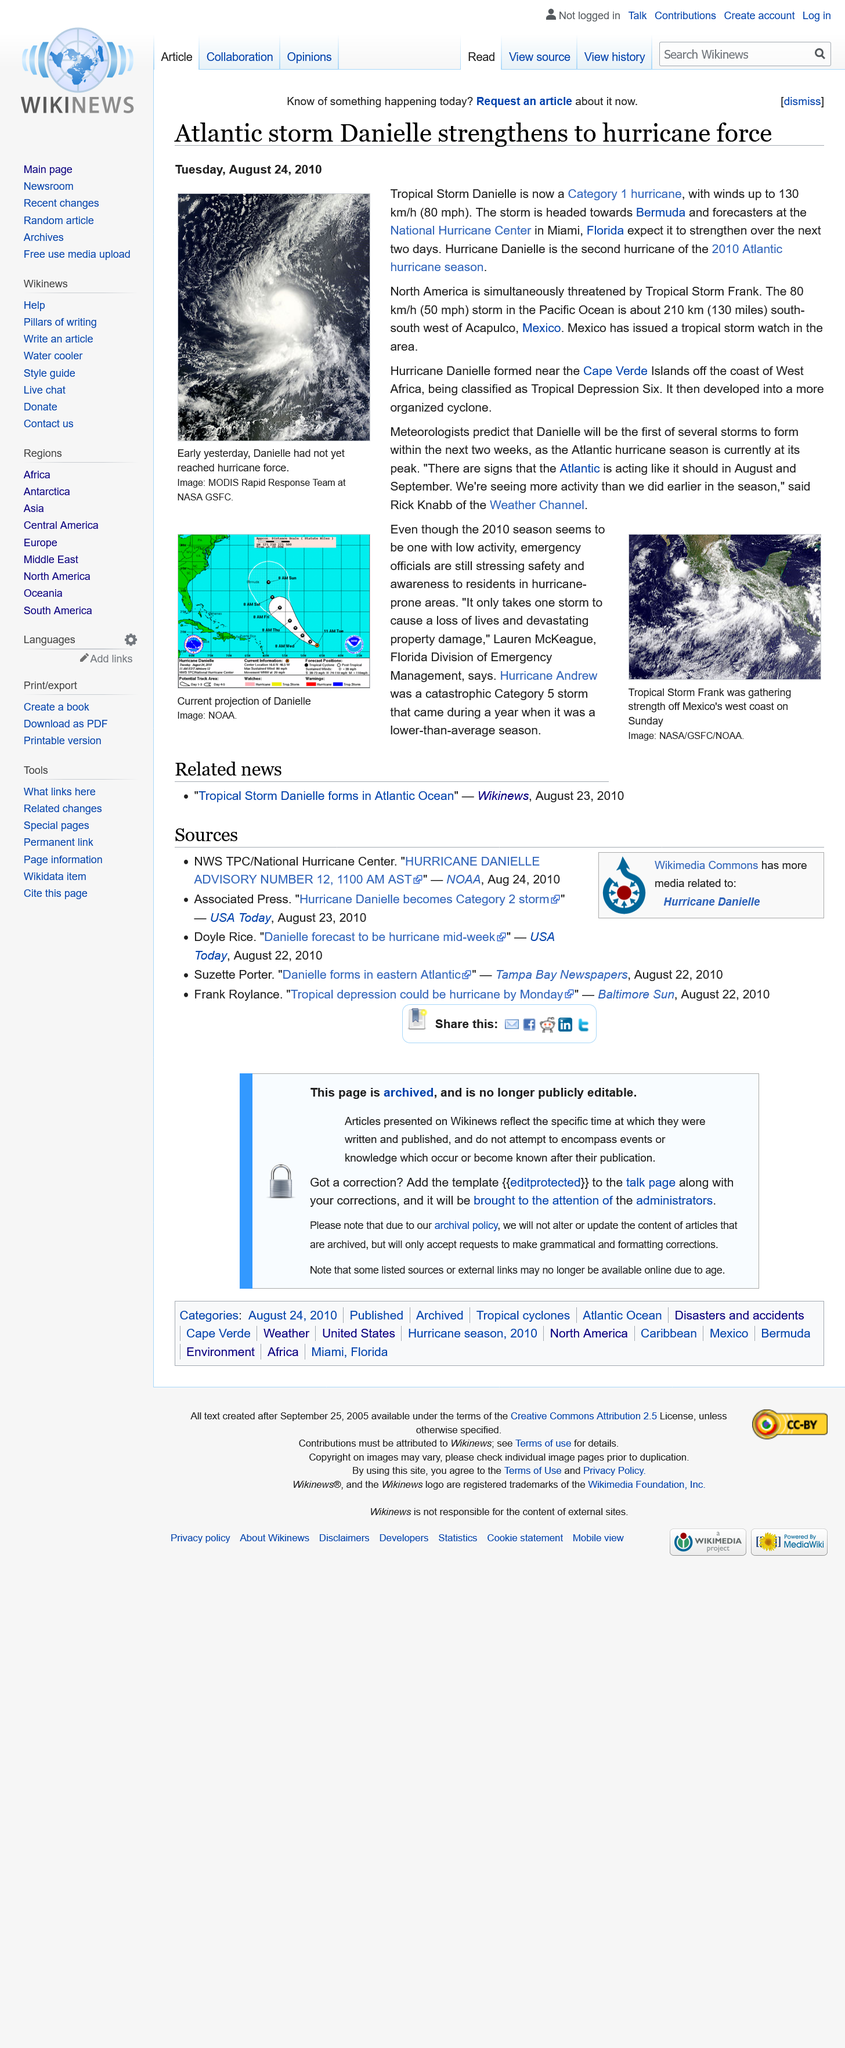Indicate a few pertinent items in this graphic. On Tuesday August 24th, Hurricane Danielle became a category 1 hurricane. Hurricane Danielle was the second hurricane of the season. Tropical Storm Frank is currently threatening North America while another storm simultaneously looms, posing a significant threat. 